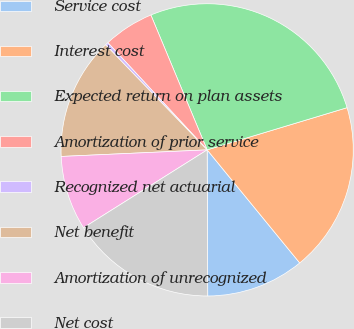<chart> <loc_0><loc_0><loc_500><loc_500><pie_chart><fcel>Service cost<fcel>Interest cost<fcel>Expected return on plan assets<fcel>Amortization of prior service<fcel>Recognized net actuarial<fcel>Net benefit<fcel>Amortization of unrecognized<fcel>Net cost<nl><fcel>10.86%<fcel>18.75%<fcel>26.64%<fcel>5.6%<fcel>0.34%<fcel>13.49%<fcel>8.23%<fcel>16.12%<nl></chart> 